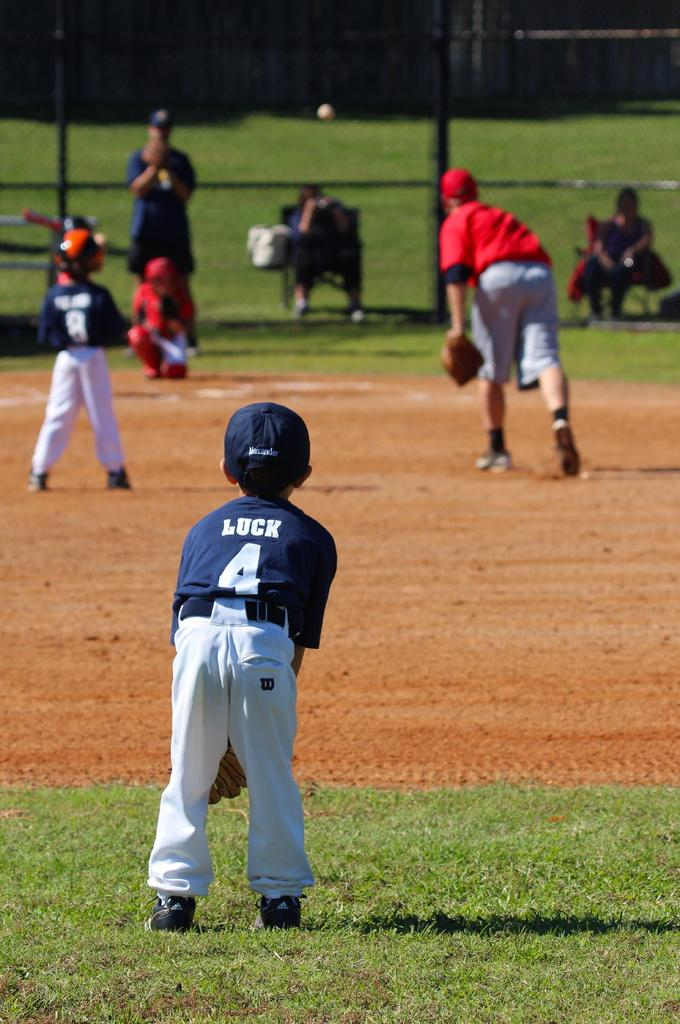Provide a one-sentence caption for the provided image. A player with Luck and number 4 on his jersey waits for the play to begin. 